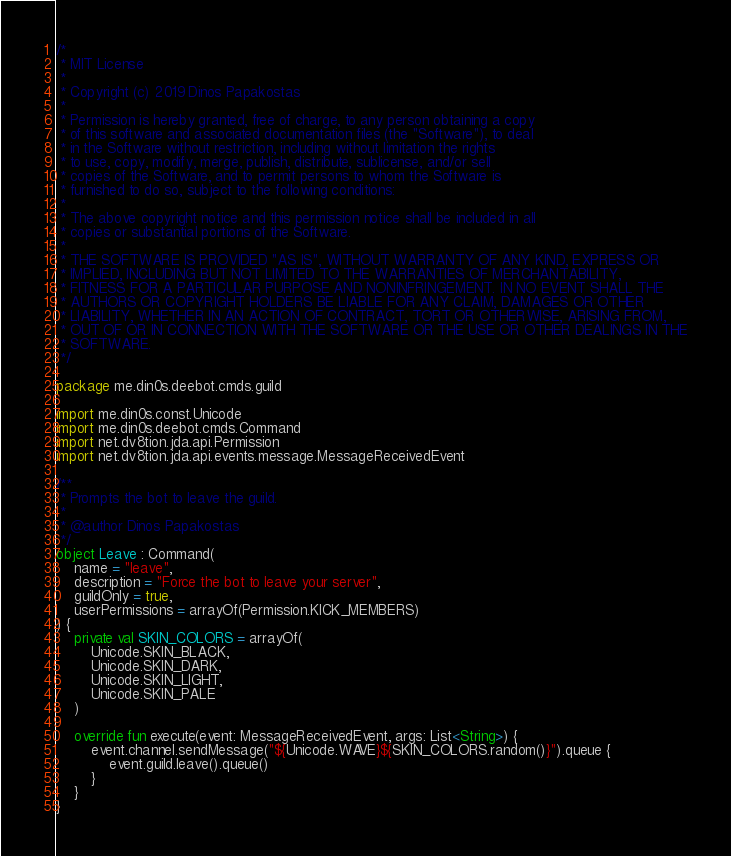<code> <loc_0><loc_0><loc_500><loc_500><_Kotlin_>/*
 * MIT License
 *
 * Copyright (c) 2019 Dinos Papakostas
 *
 * Permission is hereby granted, free of charge, to any person obtaining a copy
 * of this software and associated documentation files (the "Software"), to deal
 * in the Software without restriction, including without limitation the rights
 * to use, copy, modify, merge, publish, distribute, sublicense, and/or sell
 * copies of the Software, and to permit persons to whom the Software is
 * furnished to do so, subject to the following conditions:
 *
 * The above copyright notice and this permission notice shall be included in all
 * copies or substantial portions of the Software.
 *
 * THE SOFTWARE IS PROVIDED "AS IS", WITHOUT WARRANTY OF ANY KIND, EXPRESS OR
 * IMPLIED, INCLUDING BUT NOT LIMITED TO THE WARRANTIES OF MERCHANTABILITY,
 * FITNESS FOR A PARTICULAR PURPOSE AND NONINFRINGEMENT. IN NO EVENT SHALL THE
 * AUTHORS OR COPYRIGHT HOLDERS BE LIABLE FOR ANY CLAIM, DAMAGES OR OTHER
 * LIABILITY, WHETHER IN AN ACTION OF CONTRACT, TORT OR OTHERWISE, ARISING FROM,
 * OUT OF OR IN CONNECTION WITH THE SOFTWARE OR THE USE OR OTHER DEALINGS IN THE
 * SOFTWARE.
 */

package me.din0s.deebot.cmds.guild

import me.din0s.const.Unicode
import me.din0s.deebot.cmds.Command
import net.dv8tion.jda.api.Permission
import net.dv8tion.jda.api.events.message.MessageReceivedEvent

/**
 * Prompts the bot to leave the guild.
 *
 * @author Dinos Papakostas
 */
object Leave : Command(
    name = "leave",
    description = "Force the bot to leave your server",
    guildOnly = true,
    userPermissions = arrayOf(Permission.KICK_MEMBERS)
) {
    private val SKIN_COLORS = arrayOf(
        Unicode.SKIN_BLACK,
        Unicode.SKIN_DARK,
        Unicode.SKIN_LIGHT,
        Unicode.SKIN_PALE
    )

    override fun execute(event: MessageReceivedEvent, args: List<String>) {
        event.channel.sendMessage("${Unicode.WAVE}${SKIN_COLORS.random()}").queue {
            event.guild.leave().queue()
        }
    }
}
</code> 